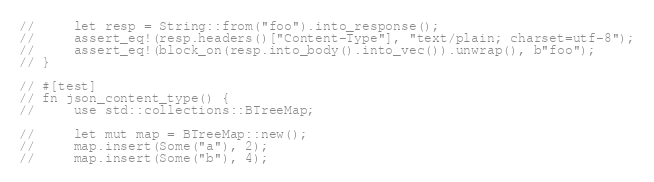Convert code to text. <code><loc_0><loc_0><loc_500><loc_500><_Rust_>//     let resp = String::from("foo").into_response();
//     assert_eq!(resp.headers()["Content-Type"], "text/plain; charset=utf-8");
//     assert_eq!(block_on(resp.into_body().into_vec()).unwrap(), b"foo");
// }

// #[test]
// fn json_content_type() {
//     use std::collections::BTreeMap;

//     let mut map = BTreeMap::new();
//     map.insert(Some("a"), 2);
//     map.insert(Some("b"), 4);</code> 